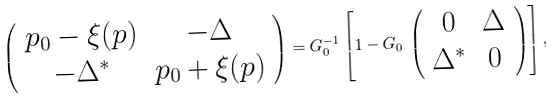<formula> <loc_0><loc_0><loc_500><loc_500>\left ( \begin{array} { c c } p _ { 0 } - \xi ( { p } ) & - \Delta \\ - \Delta ^ { * } & p _ { 0 } + \xi ( { p } ) \end{array} \right ) = G _ { 0 } ^ { - 1 } \left [ 1 - G _ { 0 } \, \left ( \begin{array} { c c } 0 & \Delta \\ \Delta ^ { * } & 0 \end{array} \right ) \right ] ,</formula> 